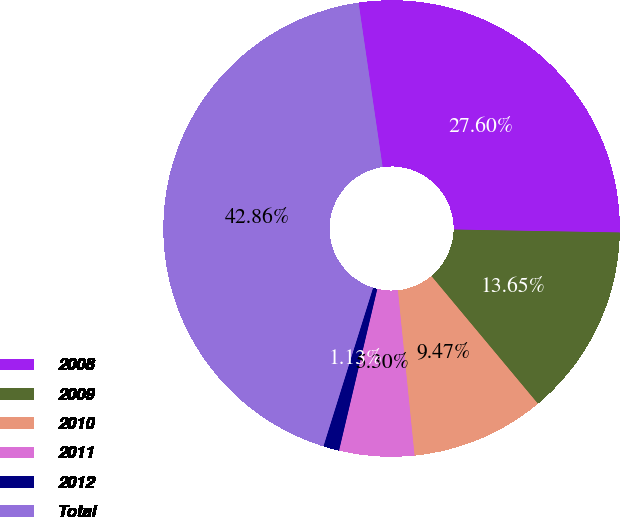Convert chart. <chart><loc_0><loc_0><loc_500><loc_500><pie_chart><fcel>2008<fcel>2009<fcel>2010<fcel>2011<fcel>2012<fcel>Total<nl><fcel>27.6%<fcel>13.65%<fcel>9.47%<fcel>5.3%<fcel>1.13%<fcel>42.86%<nl></chart> 